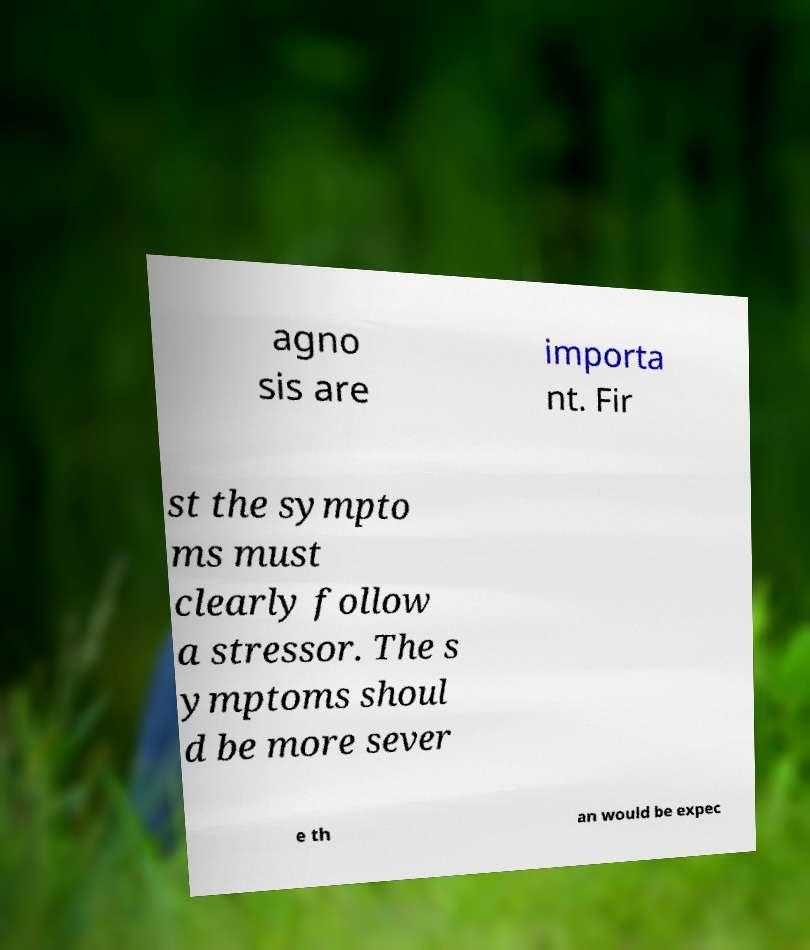There's text embedded in this image that I need extracted. Can you transcribe it verbatim? agno sis are importa nt. Fir st the sympto ms must clearly follow a stressor. The s ymptoms shoul d be more sever e th an would be expec 